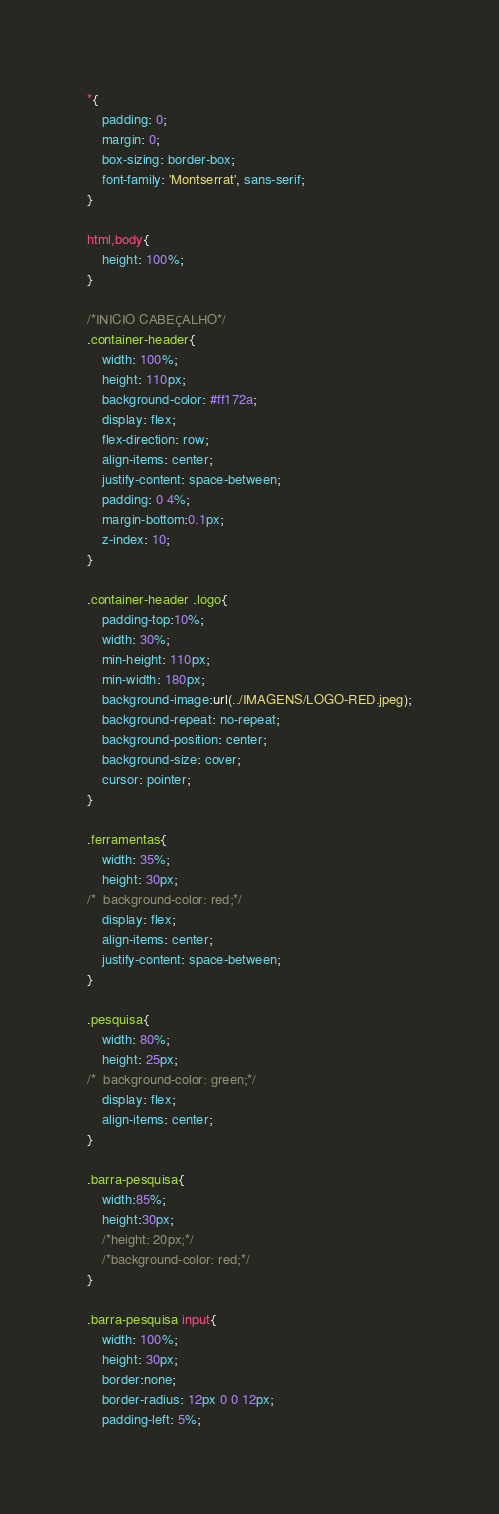Convert code to text. <code><loc_0><loc_0><loc_500><loc_500><_CSS_>*{
	padding: 0;
	margin: 0;
	box-sizing: border-box;
	font-family: 'Montserrat', sans-serif;
}

html,body{
	height: 100%;
}

/*INICIO CABEÇALHO*/
.container-header{
	width: 100%;
	height: 110px;
	background-color: #ff172a;
	display: flex;
	flex-direction: row;
	align-items: center;
	justify-content: space-between;
	padding: 0 4%;
	margin-bottom:0.1px;
	z-index: 10;
}

.container-header .logo{
	padding-top:10%;
	width: 30%;
	min-height: 110px;
	min-width: 180px;
	background-image:url(../IMAGENS/LOGO-RED.jpeg);
	background-repeat: no-repeat;
	background-position: center;
	background-size: cover;
	cursor: pointer;
}

.ferramentas{
	width: 35%;
	height: 30px;
/*	background-color: red;*/
	display: flex;
	align-items: center;
	justify-content: space-between;
}

.pesquisa{
	width: 80%;
	height: 25px;
/*	background-color: green;*/
	display: flex;
	align-items: center;
}

.barra-pesquisa{
	width:85%;
	height:30px;
	/*height: 20px;*/
	/*background-color: red;*/
}

.barra-pesquisa input{
	width: 100%;
	height: 30px;
	border:none;
	border-radius: 12px 0 0 12px;
	padding-left: 5%; </code> 